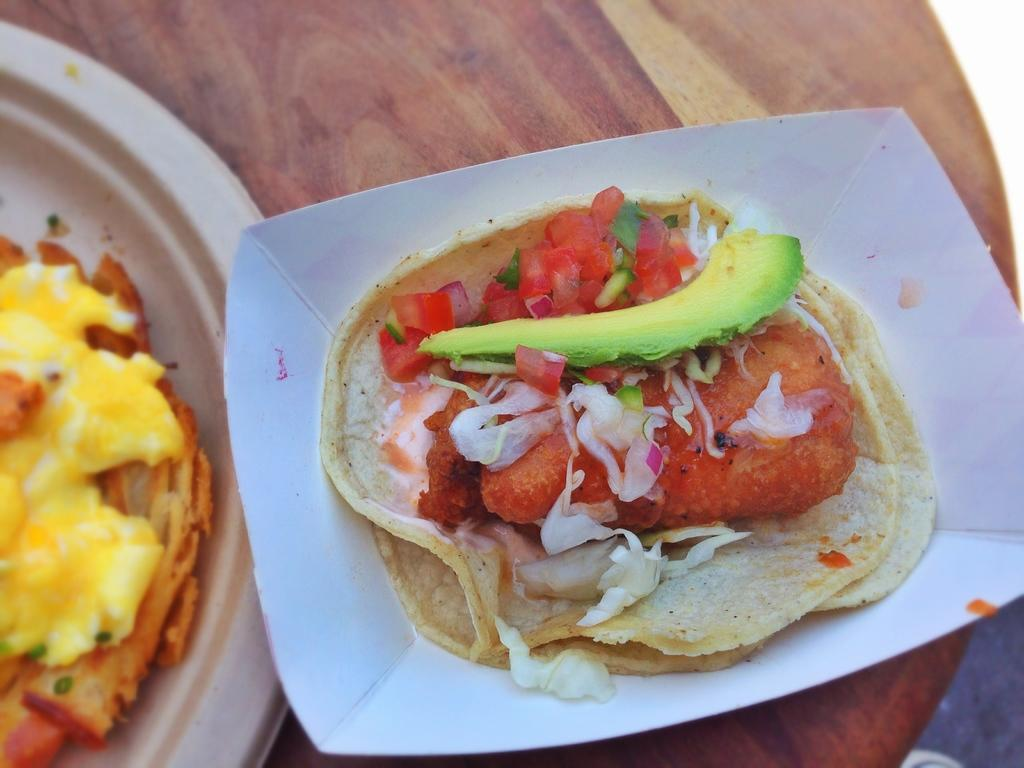What is on the plate that is visible in the image? There is food on a plate in the image. Where is the plate with food located? The plate with food is placed on a table. How many letters are on the owl in the image? There is no owl present in the image, and therefore no letters on an owl can be observed. 